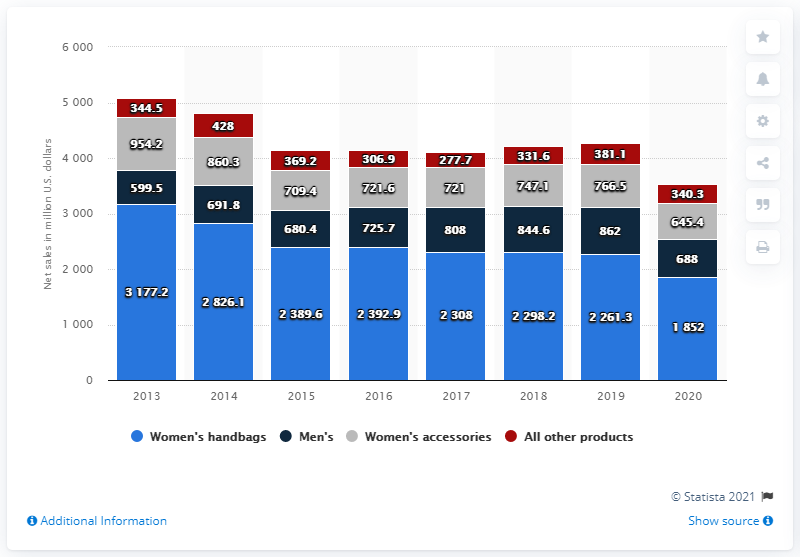List a handful of essential elements in this visual. From 2013 to 2017, the maximum sales of women's handbags fluctuated between 2,100 and 2,500 units, while the minimum sales of women's accessories ranged from 400 to 500 units. In the year 2013, the sales of women's handbags recorded the highest level of all time. In 2020, the net sales of Coach's women's handbags were 1852. 